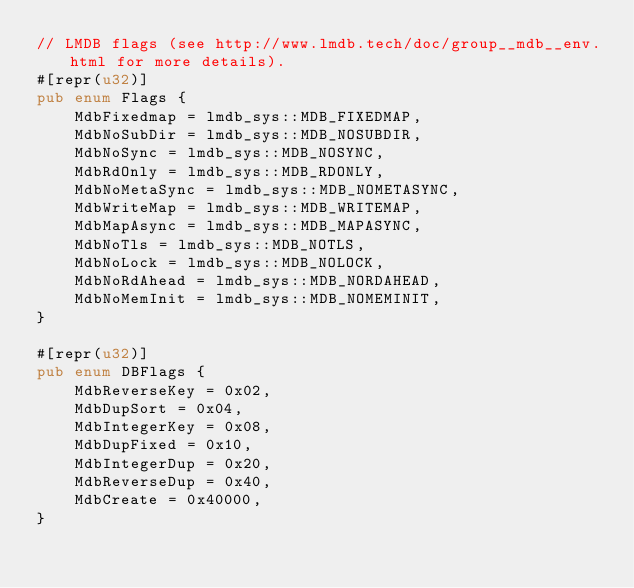<code> <loc_0><loc_0><loc_500><loc_500><_Rust_>// LMDB flags (see http://www.lmdb.tech/doc/group__mdb__env.html for more details).
#[repr(u32)]
pub enum Flags {
    MdbFixedmap = lmdb_sys::MDB_FIXEDMAP,
    MdbNoSubDir = lmdb_sys::MDB_NOSUBDIR,
    MdbNoSync = lmdb_sys::MDB_NOSYNC,
    MdbRdOnly = lmdb_sys::MDB_RDONLY,
    MdbNoMetaSync = lmdb_sys::MDB_NOMETASYNC,
    MdbWriteMap = lmdb_sys::MDB_WRITEMAP,
    MdbMapAsync = lmdb_sys::MDB_MAPASYNC,
    MdbNoTls = lmdb_sys::MDB_NOTLS,
    MdbNoLock = lmdb_sys::MDB_NOLOCK,
    MdbNoRdAhead = lmdb_sys::MDB_NORDAHEAD,
    MdbNoMemInit = lmdb_sys::MDB_NOMEMINIT,
}

#[repr(u32)]
pub enum DBFlags {
    MdbReverseKey = 0x02,
    MdbDupSort = 0x04,
    MdbIntegerKey = 0x08,
    MdbDupFixed = 0x10,
    MdbIntegerDup = 0x20,
    MdbReverseDup = 0x40,
    MdbCreate = 0x40000,
}</code> 